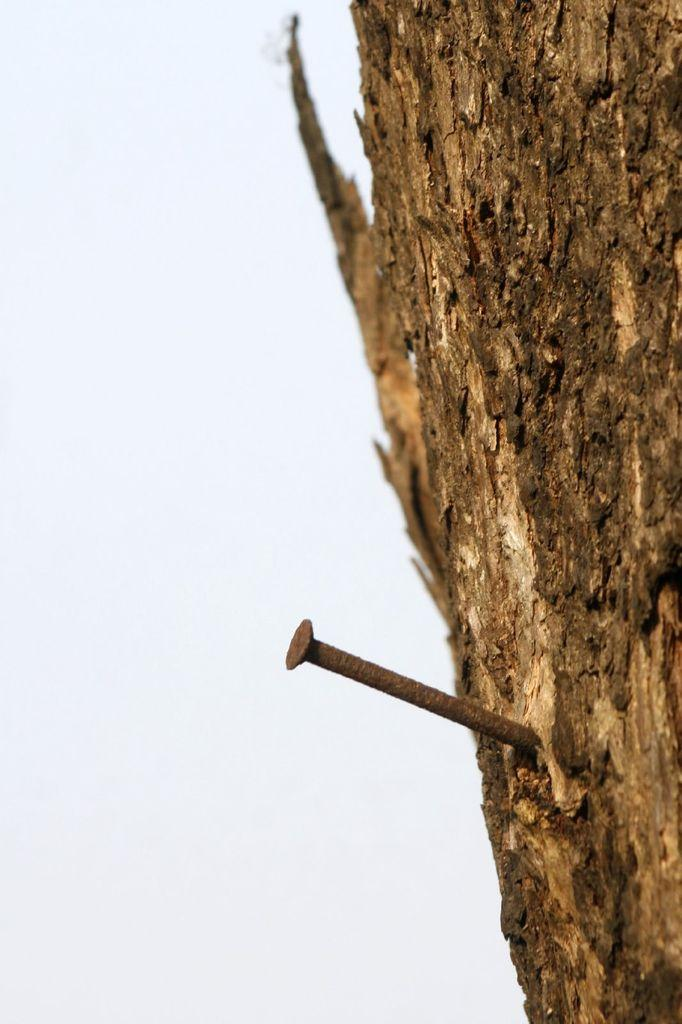What object is visible in the image? There is a brown nail in the image. Where is the nail located? The nail is inserted in the wood of a tree. What can be seen in the background of the image? The background of the image includes the sky. What type of legal advice is the nail providing in the image? The nail is not providing any legal advice in the image, as it is an inanimate object. 